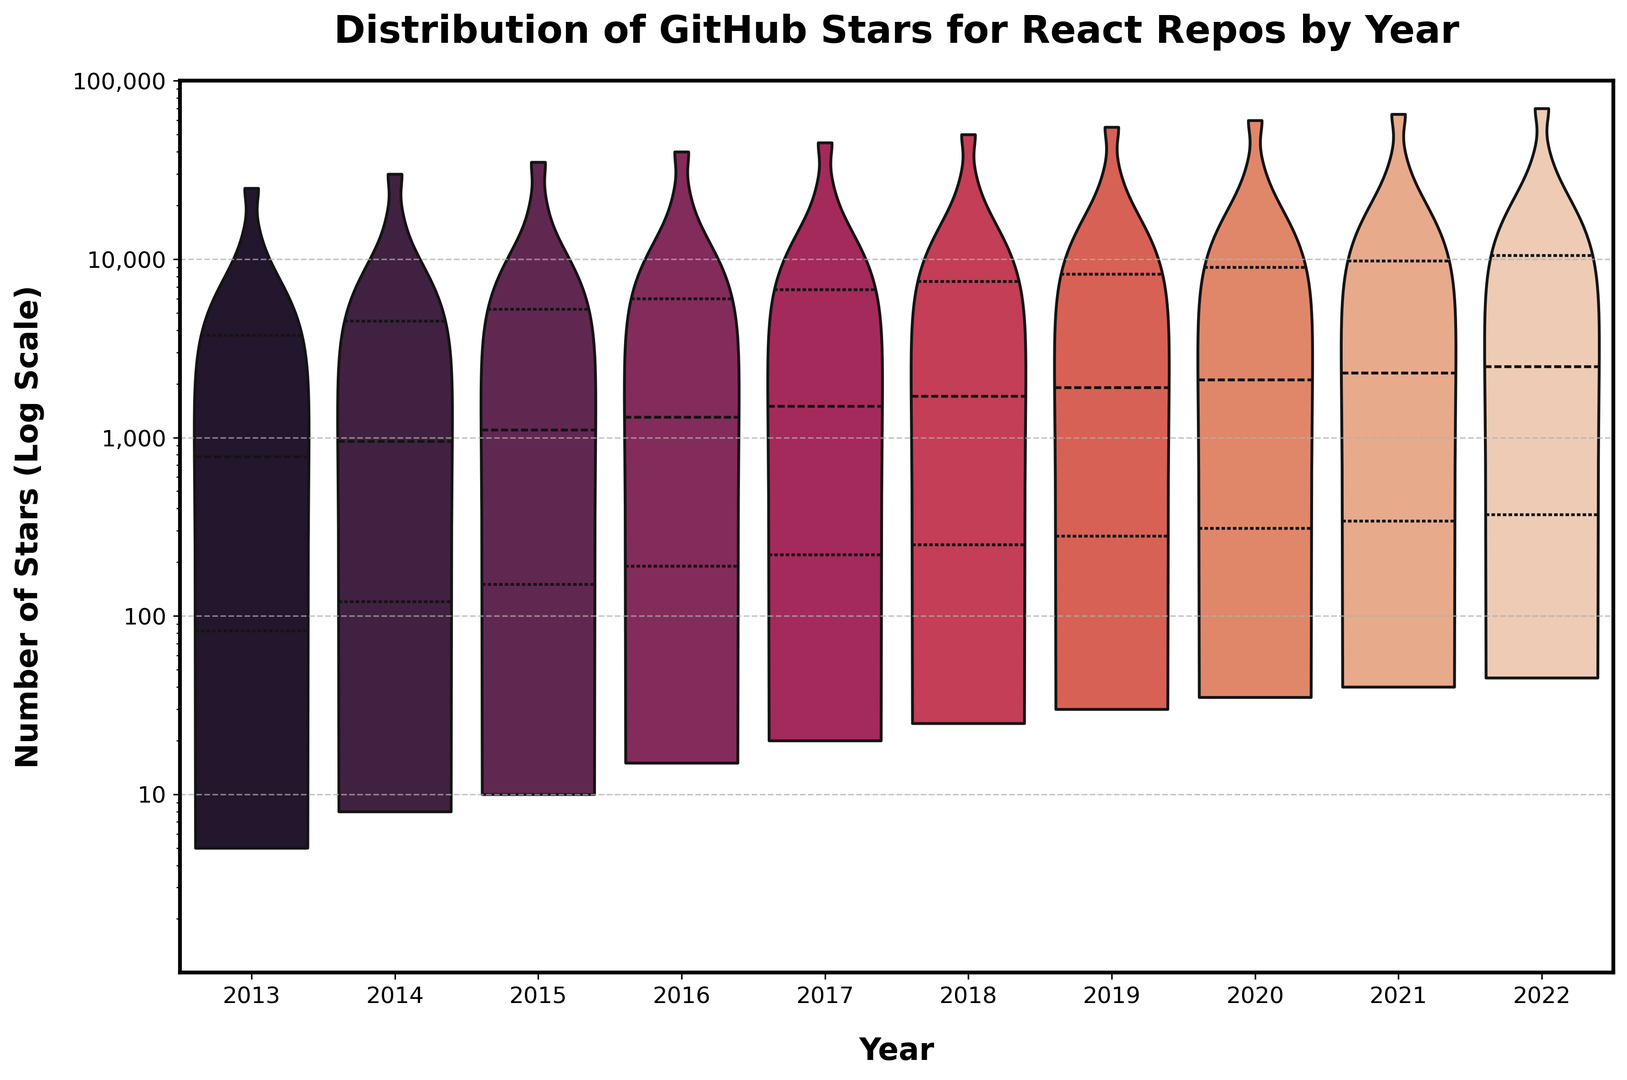What is the median number of stars for repositories created in 2015? The median value is indicated by the middle quartile marker in the violin plot for 2015. The marker shows it's around 1,800 stars.
Answer: 1,800 In which year was the variability in the distribution of stars for React repositories the highest? The width of the violin plot demonstrates variability, with 2022 showing the widest span from minimum to maximum, indicating high variability.
Answer: 2022 Compare the maximum number of stars in 2017 with that in 2018. Which year had more stars? The top point of the violin's range represents the maximum stars. For both years, 2017 and 2018, the top reaches the same point at 50,000 stars.
Answer: Equal Which year had the highest median number of stars? The median is marked by the horizontal line in each violin plot. In 2020, this line is at the highest position, around 12,000 stars.
Answer: 2020 What is the minimum number of stars for React repositories created in 2014? The bottom of the violin plot for 2014 indicates the minimum number of stars, which is approximately around 8 stars.
Answer: 8 Between 2013 and 2017, in which year were the top quartile stars the highest? The top quartile is marked by the upper inner lines within the violins. For 2017, it reaches higher than the others towards 9,000 stars.
Answer: 2017 Are there any years where the distribution of stars is skewed significantly to one side? If so, which year(s)? Skewness is observed where one part of the violin is noticeably wider than the other, indicating a concentration of data points. For 2021, the skew is towards the lower stars range.
Answer: 2021 How does the spread of stars in 2016 compare to that in 2019? The spread is observed by the width and height of the violins. Both 2016 and 2019 have a similar range but 2019 seems slightly wider at the top, indicating more high-star repositories.
Answer: 2019 What year had the smallest overall range of stars for React repositories? The range is indicated by the total height of the violin from top to bottom. 2013 shows the smallest range, from 5 stars to around 25,000 stars.
Answer: 2013 